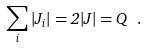<formula> <loc_0><loc_0><loc_500><loc_500>\sum _ { i } | J _ { i } | = 2 | J | = Q \ .</formula> 